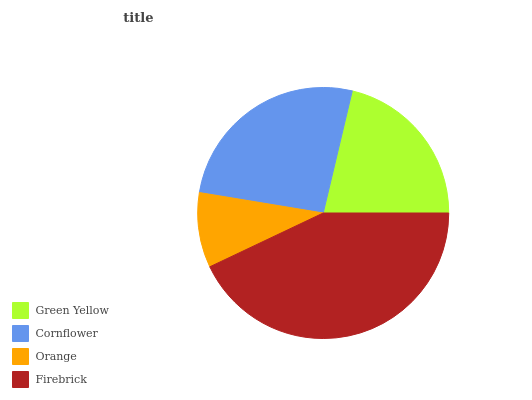Is Orange the minimum?
Answer yes or no. Yes. Is Firebrick the maximum?
Answer yes or no. Yes. Is Cornflower the minimum?
Answer yes or no. No. Is Cornflower the maximum?
Answer yes or no. No. Is Cornflower greater than Green Yellow?
Answer yes or no. Yes. Is Green Yellow less than Cornflower?
Answer yes or no. Yes. Is Green Yellow greater than Cornflower?
Answer yes or no. No. Is Cornflower less than Green Yellow?
Answer yes or no. No. Is Cornflower the high median?
Answer yes or no. Yes. Is Green Yellow the low median?
Answer yes or no. Yes. Is Orange the high median?
Answer yes or no. No. Is Firebrick the low median?
Answer yes or no. No. 